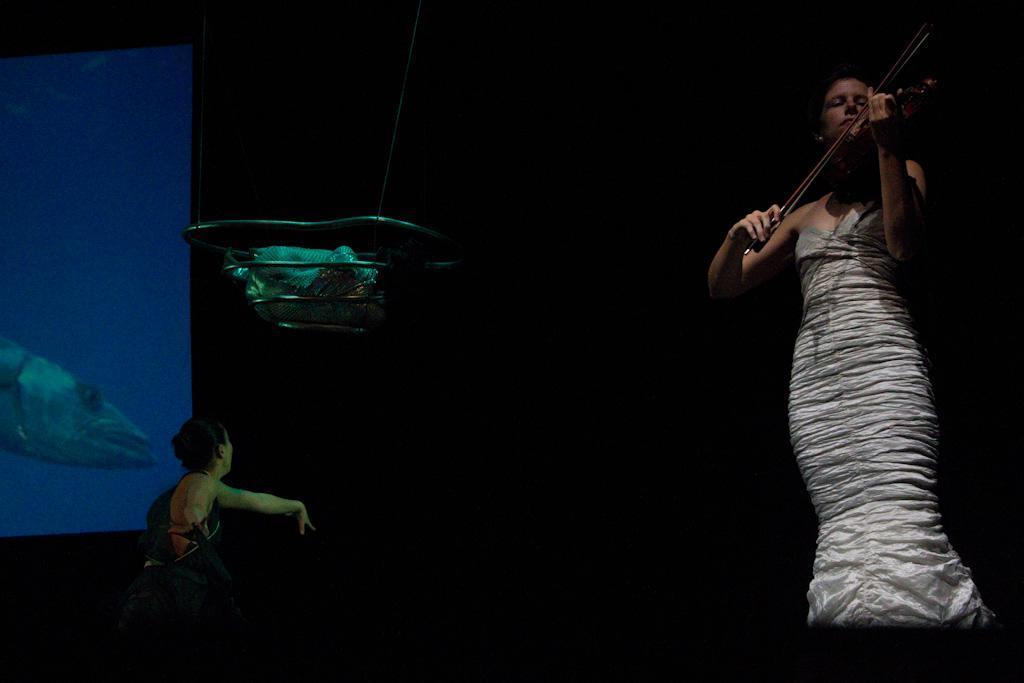Describe this image in one or two sentences. In the left bottom, there is a woman standing. In the right, woman is standing and playing violin. The background is dark in color. In the left, there is a aquarium in which fish is there half visible. This image is taken inside a dark room during night time. 